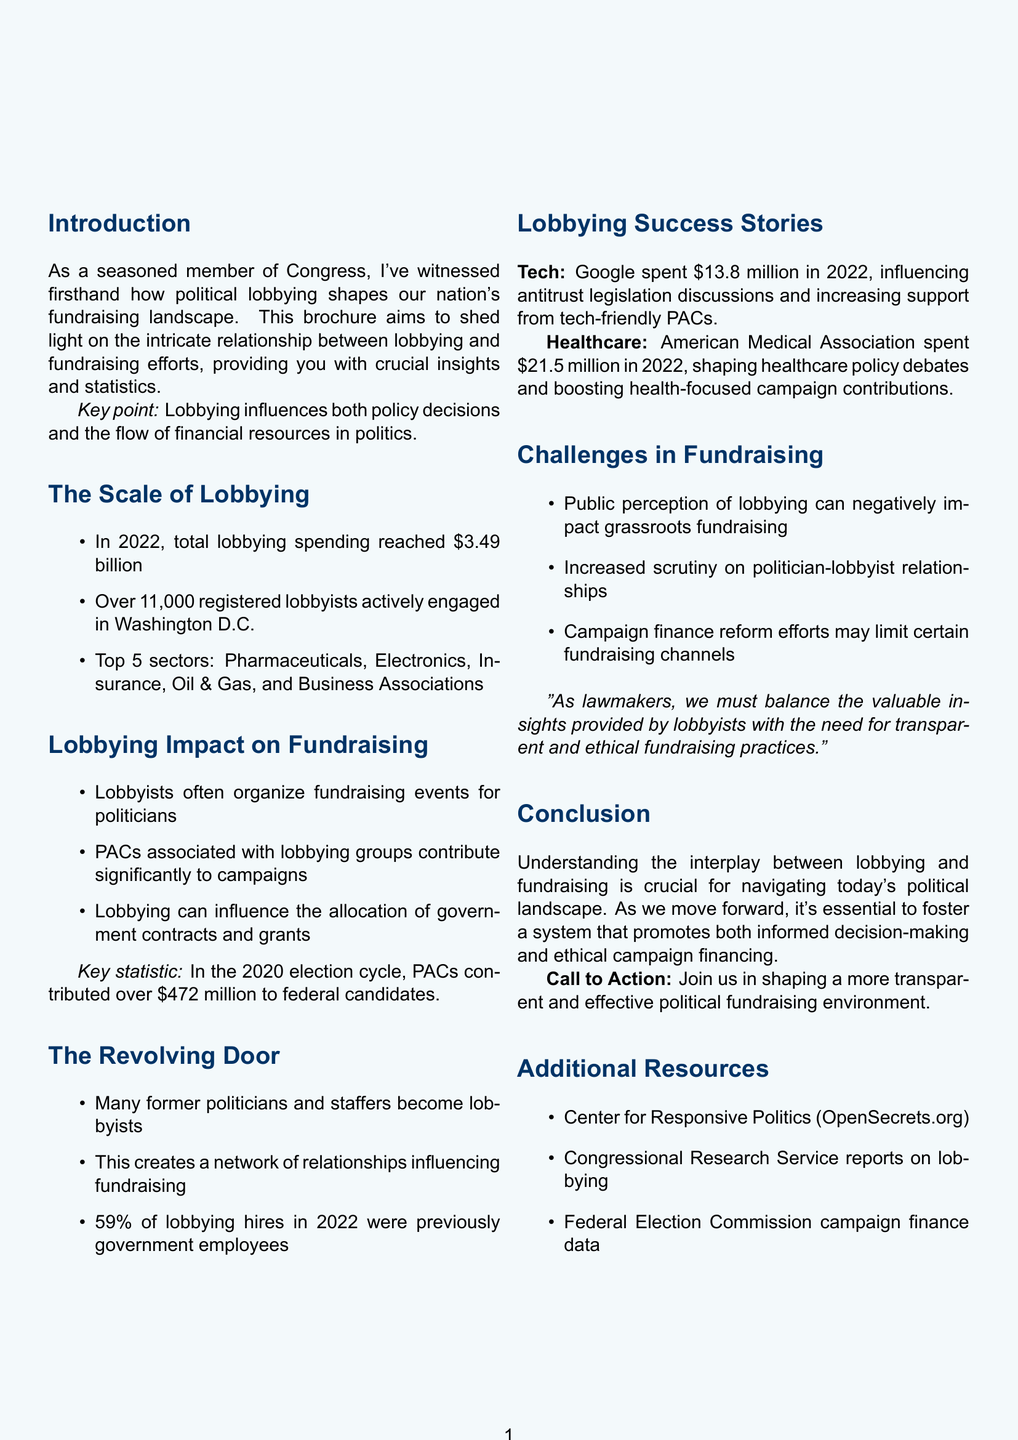What was the total lobbying spending in 2022? The document states that total lobbying spending reached $3.49 billion in 2022.
Answer: $3.49 billion How many registered lobbyists were active in Washington D.C. in 2022? According to the document, there were over 11,000 registered lobbyists actively engaged in Washington D.C.
Answer: Over 11,000 Which sector had the highest lobbying expenditure? The document lists Pharmaceuticals as one of the top sectors by lobbying expenditure.
Answer: Pharmaceuticals How much did PACs contribute to federal candidates in the 2020 election cycle? The document mentions that PACs contributed over $472 million to federal candidates in the 2020 election cycle.
Answer: Over $472 million What percentage of lobbying hires in 2022 were previously government employees? The document notes that 59% of lobbying hires in 2022 were previously government employees.
Answer: 59% What remarkable outcome resulted from Google’s lobbying efforts? The document states that Google's lobbying influenced antitrust legislation discussions.
Answer: Influenced antitrust legislation discussions What is a challenge mentioned in fundraising efforts? The document indicates that public perception of lobbying can negatively impact grassroots fundraising.
Answer: Public perception of lobbying What type of document is this? This is a brochure that highlights the impact of political lobbying on fundraising efforts.
Answer: Brochure What does the call to action encourage readers to do? The document encourages readers to join in shaping a more transparent and effective political fundraising environment.
Answer: Shape a more transparent and effective political fundraising environment 